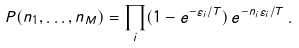<formula> <loc_0><loc_0><loc_500><loc_500>P ( n _ { 1 } , \dots , n _ { M } ) = \prod _ { i } ( 1 - e ^ { - \varepsilon _ { i } / T } ) \, e ^ { - n _ { i } \varepsilon _ { i } / T } \, .</formula> 